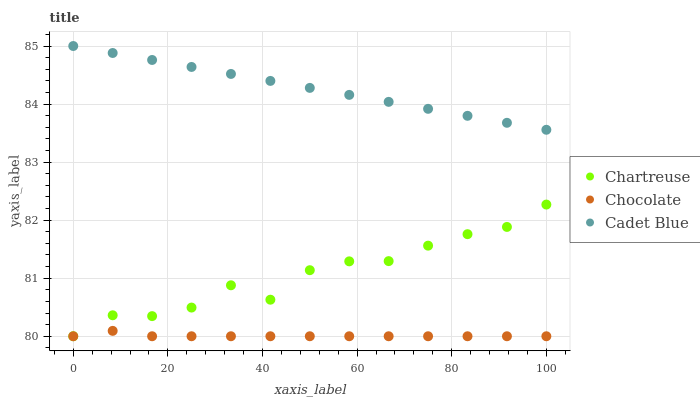Does Chocolate have the minimum area under the curve?
Answer yes or no. Yes. Does Cadet Blue have the maximum area under the curve?
Answer yes or no. Yes. Does Cadet Blue have the minimum area under the curve?
Answer yes or no. No. Does Chocolate have the maximum area under the curve?
Answer yes or no. No. Is Cadet Blue the smoothest?
Answer yes or no. Yes. Is Chartreuse the roughest?
Answer yes or no. Yes. Is Chocolate the smoothest?
Answer yes or no. No. Is Chocolate the roughest?
Answer yes or no. No. Does Chartreuse have the lowest value?
Answer yes or no. Yes. Does Cadet Blue have the lowest value?
Answer yes or no. No. Does Cadet Blue have the highest value?
Answer yes or no. Yes. Does Chocolate have the highest value?
Answer yes or no. No. Is Chocolate less than Cadet Blue?
Answer yes or no. Yes. Is Cadet Blue greater than Chocolate?
Answer yes or no. Yes. Does Chocolate intersect Chartreuse?
Answer yes or no. Yes. Is Chocolate less than Chartreuse?
Answer yes or no. No. Is Chocolate greater than Chartreuse?
Answer yes or no. No. Does Chocolate intersect Cadet Blue?
Answer yes or no. No. 